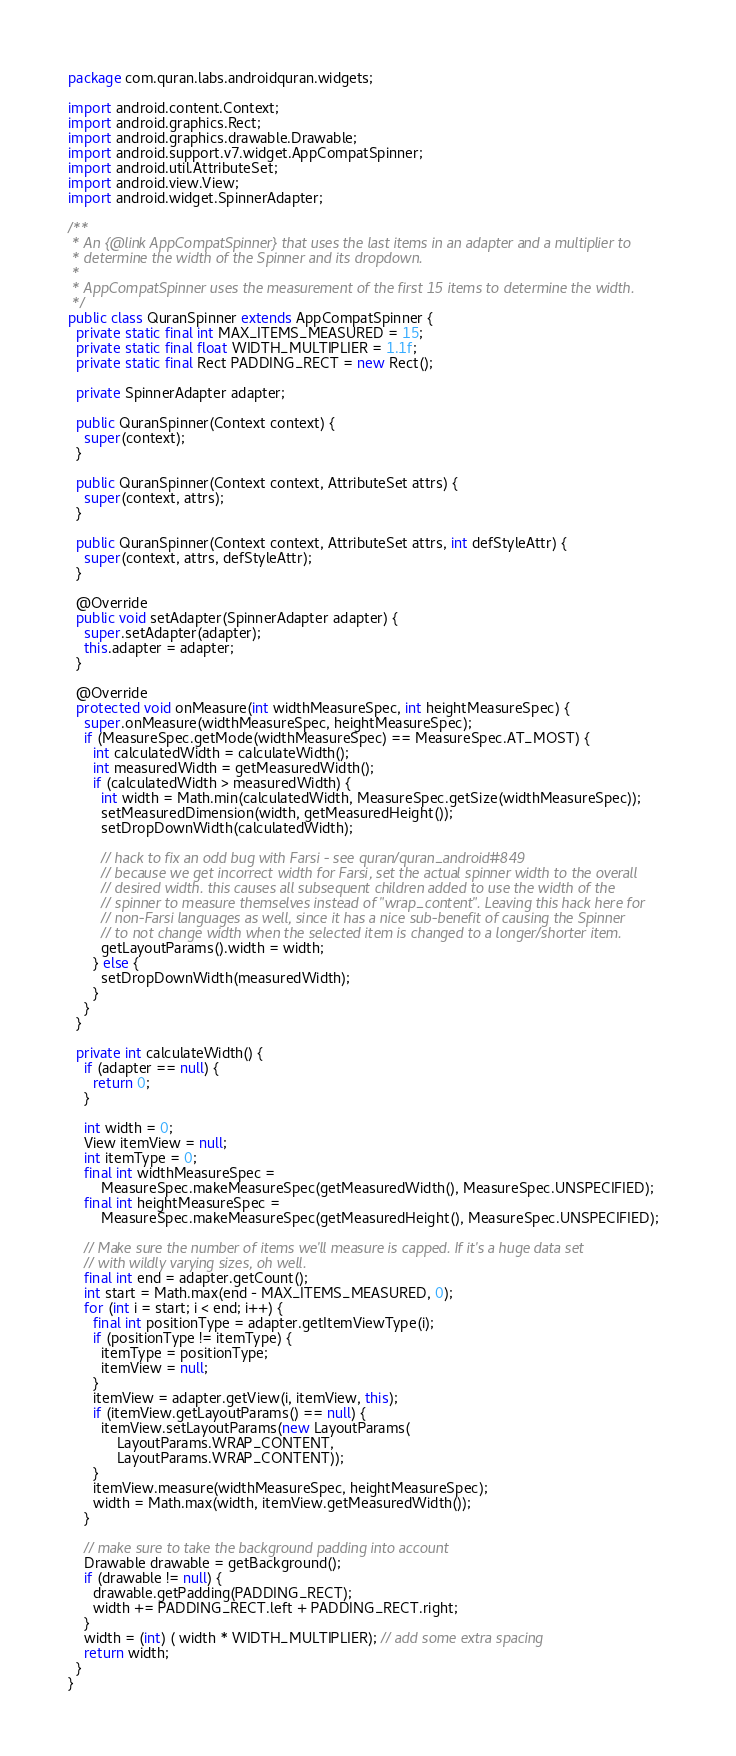<code> <loc_0><loc_0><loc_500><loc_500><_Java_>package com.quran.labs.androidquran.widgets;

import android.content.Context;
import android.graphics.Rect;
import android.graphics.drawable.Drawable;
import android.support.v7.widget.AppCompatSpinner;
import android.util.AttributeSet;
import android.view.View;
import android.widget.SpinnerAdapter;

/**
 * An {@link AppCompatSpinner} that uses the last items in an adapter and a multiplier to
 * determine the width of the Spinner and its dropdown.
 *
 * AppCompatSpinner uses the measurement of the first 15 items to determine the width.
 */
public class QuranSpinner extends AppCompatSpinner {
  private static final int MAX_ITEMS_MEASURED = 15;
  private static final float WIDTH_MULTIPLIER = 1.1f;
  private static final Rect PADDING_RECT = new Rect();

  private SpinnerAdapter adapter;

  public QuranSpinner(Context context) {
    super(context);
  }

  public QuranSpinner(Context context, AttributeSet attrs) {
    super(context, attrs);
  }

  public QuranSpinner(Context context, AttributeSet attrs, int defStyleAttr) {
    super(context, attrs, defStyleAttr);
  }

  @Override
  public void setAdapter(SpinnerAdapter adapter) {
    super.setAdapter(adapter);
    this.adapter = adapter;
  }

  @Override
  protected void onMeasure(int widthMeasureSpec, int heightMeasureSpec) {
    super.onMeasure(widthMeasureSpec, heightMeasureSpec);
    if (MeasureSpec.getMode(widthMeasureSpec) == MeasureSpec.AT_MOST) {
      int calculatedWidth = calculateWidth();
      int measuredWidth = getMeasuredWidth();
      if (calculatedWidth > measuredWidth) {
        int width = Math.min(calculatedWidth, MeasureSpec.getSize(widthMeasureSpec));
        setMeasuredDimension(width, getMeasuredHeight());
        setDropDownWidth(calculatedWidth);

        // hack to fix an odd bug with Farsi - see quran/quran_android#849
        // because we get incorrect width for Farsi, set the actual spinner width to the overall
        // desired width. this causes all subsequent children added to use the width of the
        // spinner to measure themselves instead of "wrap_content". Leaving this hack here for
        // non-Farsi languages as well, since it has a nice sub-benefit of causing the Spinner
        // to not change width when the selected item is changed to a longer/shorter item.
        getLayoutParams().width = width;
      } else {
        setDropDownWidth(measuredWidth);
      }
    }
  }

  private int calculateWidth() {
    if (adapter == null) {
      return 0;
    }

    int width = 0;
    View itemView = null;
    int itemType = 0;
    final int widthMeasureSpec =
        MeasureSpec.makeMeasureSpec(getMeasuredWidth(), MeasureSpec.UNSPECIFIED);
    final int heightMeasureSpec =
        MeasureSpec.makeMeasureSpec(getMeasuredHeight(), MeasureSpec.UNSPECIFIED);

    // Make sure the number of items we'll measure is capped. If it's a huge data set
    // with wildly varying sizes, oh well.
    final int end = adapter.getCount();
    int start = Math.max(end - MAX_ITEMS_MEASURED, 0);
    for (int i = start; i < end; i++) {
      final int positionType = adapter.getItemViewType(i);
      if (positionType != itemType) {
        itemType = positionType;
        itemView = null;
      }
      itemView = adapter.getView(i, itemView, this);
      if (itemView.getLayoutParams() == null) {
        itemView.setLayoutParams(new LayoutParams(
            LayoutParams.WRAP_CONTENT,
            LayoutParams.WRAP_CONTENT));
      }
      itemView.measure(widthMeasureSpec, heightMeasureSpec);
      width = Math.max(width, itemView.getMeasuredWidth());
    }

    // make sure to take the background padding into account
    Drawable drawable = getBackground();
    if (drawable != null) {
      drawable.getPadding(PADDING_RECT);
      width += PADDING_RECT.left + PADDING_RECT.right;
    }
    width = (int) ( width * WIDTH_MULTIPLIER); // add some extra spacing
    return width;
  }
}
</code> 